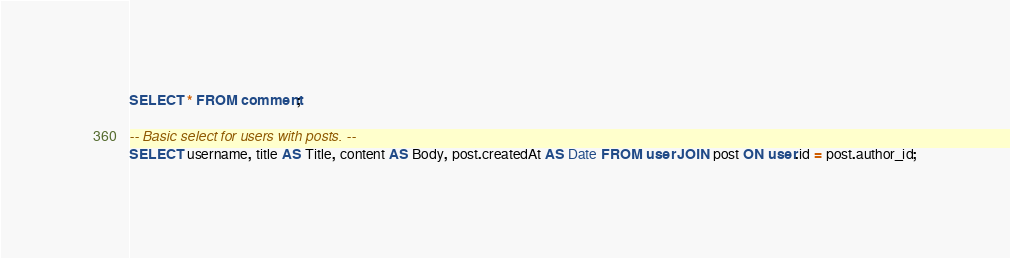Convert code to text. <code><loc_0><loc_0><loc_500><loc_500><_SQL_>
SELECT * FROM comment;

-- Basic select for users with posts. --
SELECT username, title AS Title, content AS Body, post.createdAt AS Date FROM user JOIN post ON user.id = post.author_id;</code> 